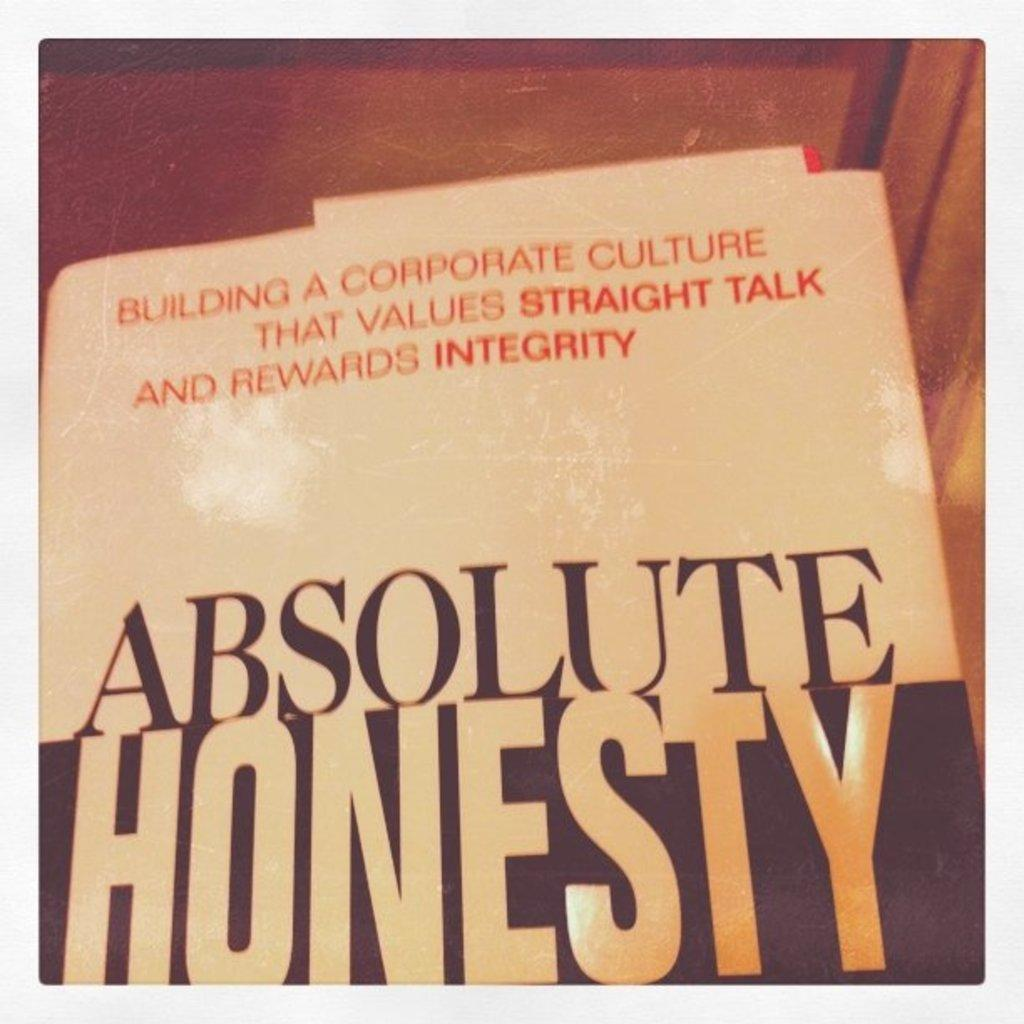<image>
Summarize the visual content of the image. the word honesty is on a book that has a light and dark cover 